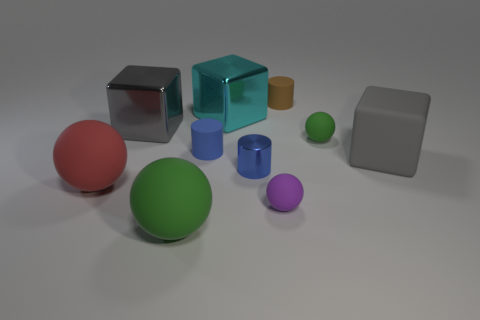There is a red matte thing that is the same shape as the purple object; what is its size?
Provide a succinct answer. Large. What material is the green ball that is to the right of the small matte cylinder that is in front of the ball behind the big red thing?
Ensure brevity in your answer.  Rubber. Are any small cyan things visible?
Ensure brevity in your answer.  No. Is the color of the tiny metallic object the same as the cylinder on the left side of the cyan shiny thing?
Your answer should be very brief. Yes. The large rubber block has what color?
Make the answer very short. Gray. What color is the other big object that is the same shape as the big red matte thing?
Give a very brief answer. Green. Is the shape of the big green object the same as the cyan thing?
Ensure brevity in your answer.  No. What number of spheres are either small green things or large metal objects?
Your answer should be compact. 1. The other small ball that is the same material as the tiny purple sphere is what color?
Ensure brevity in your answer.  Green. There is a green sphere in front of the red sphere; is it the same size as the tiny purple matte sphere?
Your answer should be compact. No. 